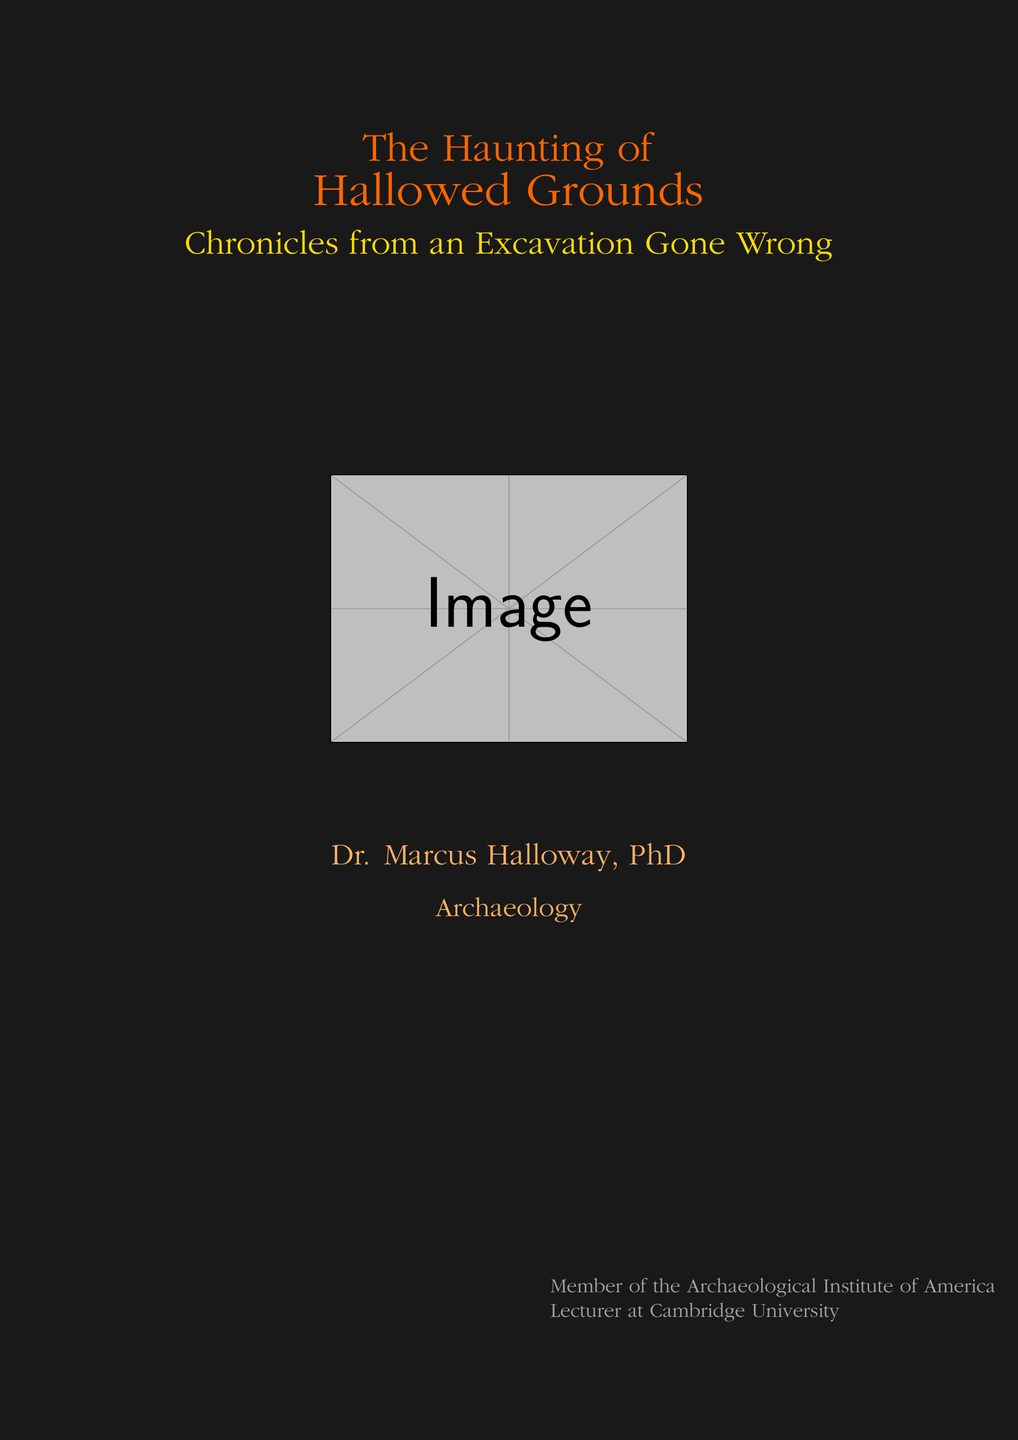what is the title of the book? The title is prominently displayed in the center of the document, stating the main focus of the narrative.
Answer: The Haunting of Hallowed Grounds who is the author of the book? The author's name is listed towards the bottom of the cover, indicating the individual responsible for the content.
Answer: Dr. Marcus Halloway, PhD what is the subtitle of the book? The subtitle provides further context about the book's focus and is located directly beneath the main title.
Answer: Chronicles from an Excavation Gone Wrong what is the profession of the author? The author's profession is mentioned in a stylized font beneath the author's name, indicating their area of expertise.
Answer: Archaeology which organization is the author a member of? The document mentions a specific association connected to the author's professional credentials at the bottom left of the cover.
Answer: Archaeological Institute of America what visual elements are on the book cover? The cover features specific elements that create an atmosphere, contributing to the theme of the book.
Answer: Ancient artifact, archaeological tools, shadowy figure what color is the title text? The color used for the title is indicated in the document, which gives the title a distinct appearance.
Answer: Orange!80!red what is the overall theme of the book? The theme can be inferred from the description found in the middle section of the cover, reflecting the narrative's essence.
Answer: Supernatural consequences and ancient history 